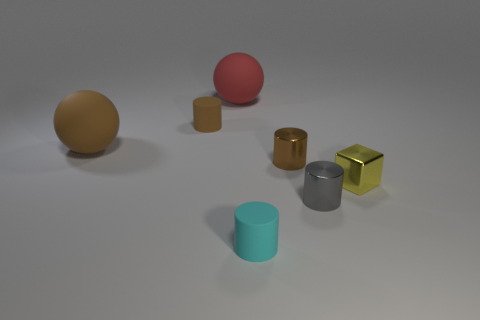Are there more blue rubber objects than large brown things?
Ensure brevity in your answer.  No. What shape is the big thing that is in front of the matte cylinder behind the yellow block?
Ensure brevity in your answer.  Sphere. There is a matte sphere that is in front of the brown cylinder that is on the left side of the red rubber thing; are there any small gray metal cylinders that are left of it?
Provide a short and direct response. No. The other rubber object that is the same size as the cyan thing is what color?
Provide a succinct answer. Brown. There is a rubber thing that is both in front of the brown rubber cylinder and left of the red rubber thing; what shape is it?
Make the answer very short. Sphere. There is a rubber ball to the left of the small cylinder that is behind the large brown matte thing; what is its size?
Ensure brevity in your answer.  Large. What number of other objects are there of the same size as the metal cube?
Offer a very short reply. 4. How big is the object that is right of the small cyan cylinder and on the left side of the small gray metallic thing?
Keep it short and to the point. Small. How many cyan objects have the same shape as the red object?
Keep it short and to the point. 0. What material is the tiny block?
Ensure brevity in your answer.  Metal. 